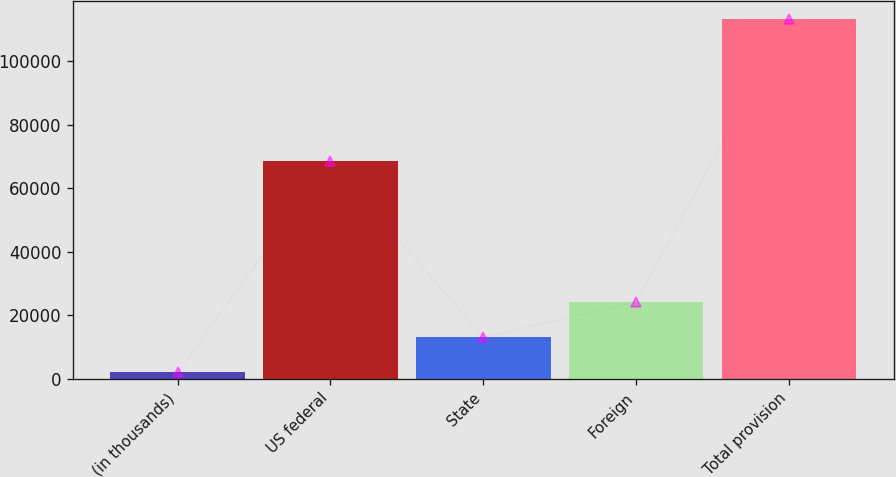<chart> <loc_0><loc_0><loc_500><loc_500><bar_chart><fcel>(in thousands)<fcel>US federal<fcel>State<fcel>Foreign<fcel>Total provision<nl><fcel>2008<fcel>68469<fcel>13115<fcel>24222<fcel>113078<nl></chart> 